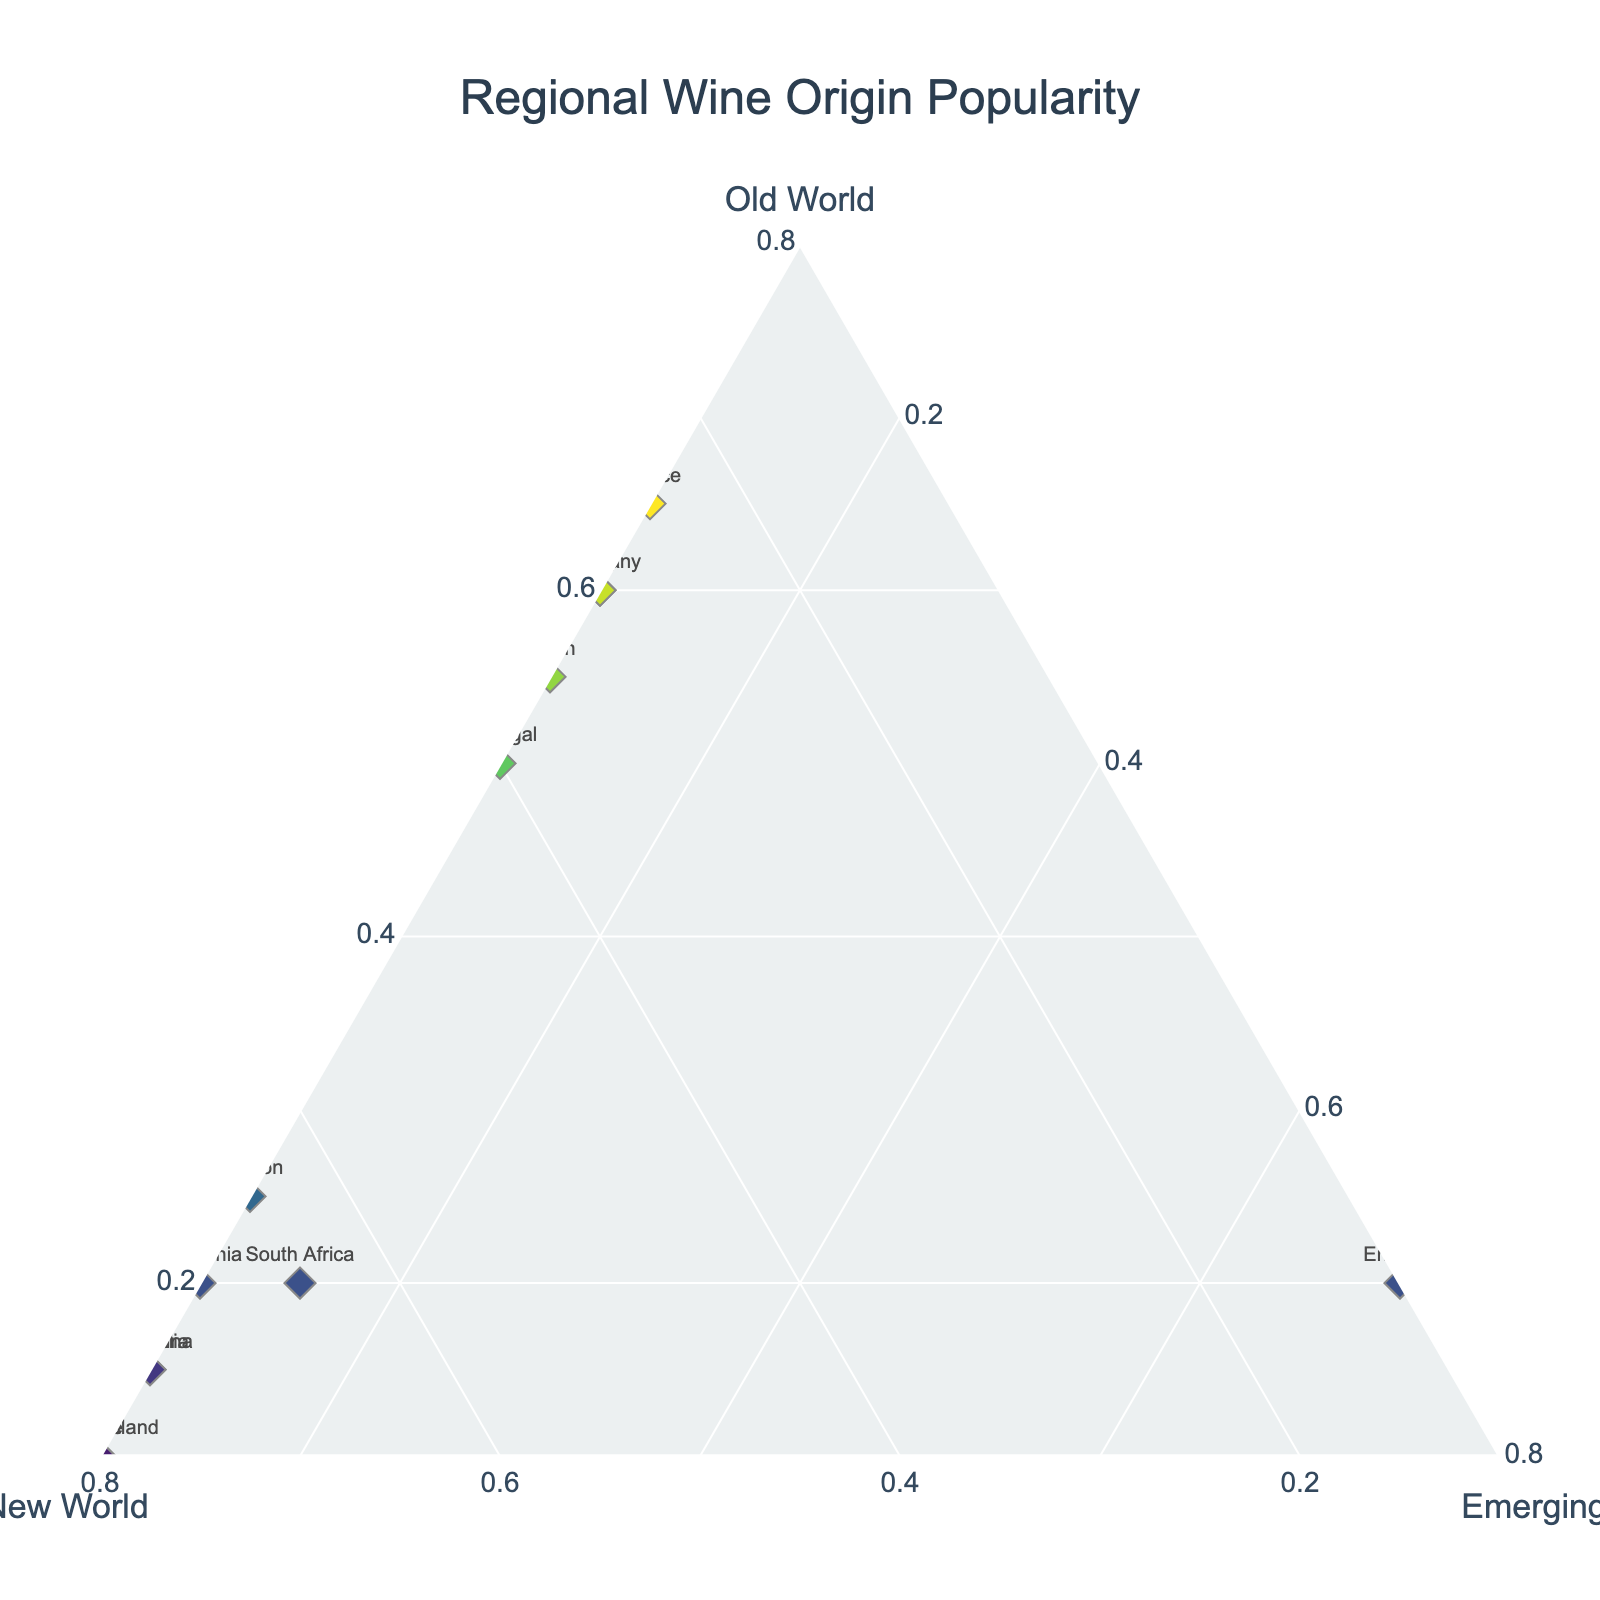what is the title of the figure? The title of the figure is displayed at the top center of the plot area.
Answer: "Regional Wine Origin Popularity" How many regions are represented in the plot? Each data point on the ternary plot represents a region, and there are a total of 14 different regions listed in the data.
Answer: 14 Which regions are classified as having the highest popularity for New World wines? New World popularity is represented by the 'b' axis, so regions with higher New World values will be further towards the b-axis vertex. New Zealand, Chile, and Australia have the highest values for New World wines (0.80, 0.80, and 0.75, respectively).
Answer: New Zealand, Chile, and Australia Which region has the most significant proportion of emerging wine regions? Proportions are represented by the ternary plot vertices. China has the highest value for Emerging wines with a proportion of 0.80.
Answer: China What is the average popularity of Old World wines across all regions? Calculate the average by summing all the Old World values and dividing by the number of regions: (0.65+0.60+0.20+0.15+0.10+0.15+0.55+0.60+0.20+0.10+0.50+0.25+0.05+0.20)/14.
Answer: 0.32 Which two regions have the closest performance in terms of New World wine popularity? To determine the closest values, compare the New World values: Spain (0.35) and Portugal (0.40) differ only by 0.05.
Answer: Spain and Portugal Is there any region which has an equal proportion of Old World and New World popularity? Check if any region has the same values for Old World and New World proportions; none of the regions have equal values for both.
Answer: No Between France and Italy, which region has a greater popularity in Old World wines? France's Old World proportion is 0.65 and Italy's is 0.60, so France has a higher Old World popularity.
Answer: France 